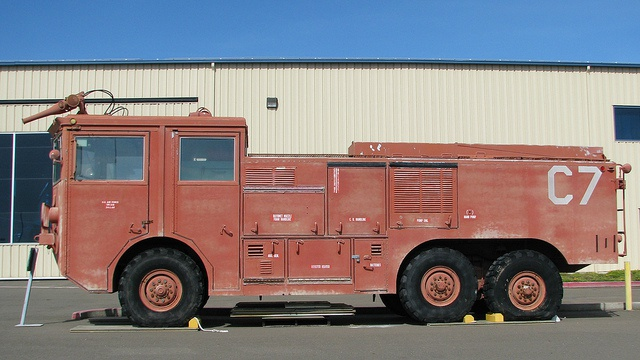Describe the objects in this image and their specific colors. I can see a truck in gray, brown, black, and maroon tones in this image. 